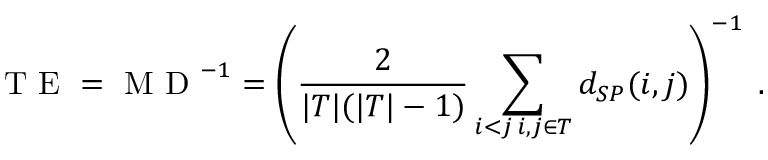Convert formula to latex. <formula><loc_0><loc_0><loc_500><loc_500>T E = M D ^ { - 1 } = \left ( \frac { 2 } { | T | ( | T | - 1 ) } \sum _ { \substack { i < j \, i , j \in T } } d _ { S P } ( i , j ) \right ) ^ { - 1 } \, .</formula> 